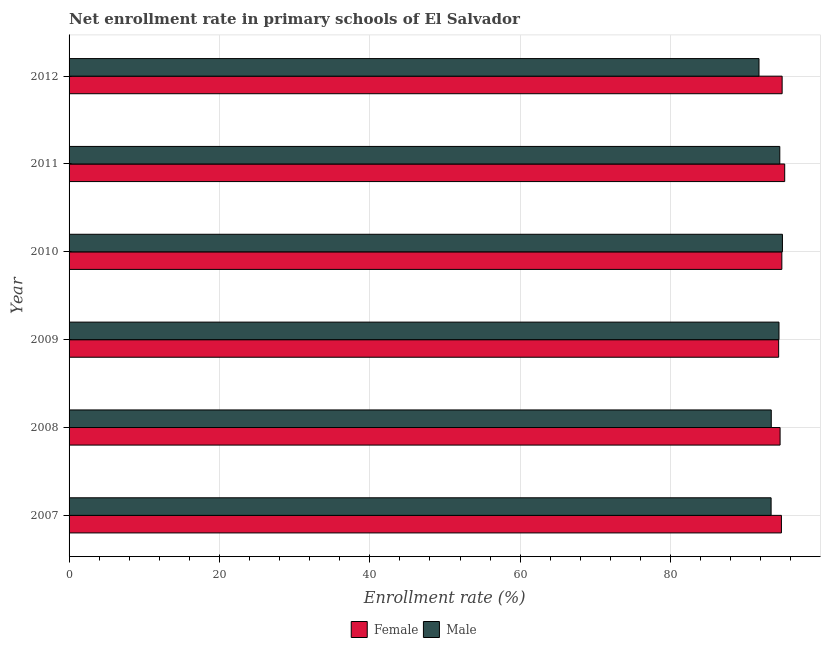How many different coloured bars are there?
Offer a very short reply. 2. How many groups of bars are there?
Provide a short and direct response. 6. Are the number of bars on each tick of the Y-axis equal?
Your answer should be very brief. Yes. In how many cases, is the number of bars for a given year not equal to the number of legend labels?
Your response must be concise. 0. What is the enrollment rate of female students in 2011?
Your answer should be very brief. 95.19. Across all years, what is the maximum enrollment rate of male students?
Make the answer very short. 94.89. Across all years, what is the minimum enrollment rate of male students?
Provide a short and direct response. 91.77. In which year was the enrollment rate of male students maximum?
Offer a very short reply. 2010. What is the total enrollment rate of female students in the graph?
Your response must be concise. 568.55. What is the difference between the enrollment rate of female students in 2007 and that in 2008?
Your answer should be compact. 0.18. What is the difference between the enrollment rate of female students in 2010 and the enrollment rate of male students in 2012?
Give a very brief answer. 3.04. What is the average enrollment rate of male students per year?
Provide a succinct answer. 93.73. In the year 2007, what is the difference between the enrollment rate of female students and enrollment rate of male students?
Keep it short and to the point. 1.37. What is the difference between the highest and the second highest enrollment rate of female students?
Your answer should be very brief. 0.34. What is the difference between the highest and the lowest enrollment rate of male students?
Your answer should be very brief. 3.12. In how many years, is the enrollment rate of male students greater than the average enrollment rate of male students taken over all years?
Your answer should be compact. 3. What does the 2nd bar from the top in 2011 represents?
Provide a succinct answer. Female. What does the 1st bar from the bottom in 2008 represents?
Ensure brevity in your answer.  Female. How many bars are there?
Offer a very short reply. 12. How many years are there in the graph?
Ensure brevity in your answer.  6. What is the difference between two consecutive major ticks on the X-axis?
Offer a very short reply. 20. Does the graph contain any zero values?
Offer a terse response. No. Does the graph contain grids?
Your answer should be compact. Yes. Where does the legend appear in the graph?
Keep it short and to the point. Bottom center. How many legend labels are there?
Make the answer very short. 2. How are the legend labels stacked?
Offer a terse response. Horizontal. What is the title of the graph?
Provide a short and direct response. Net enrollment rate in primary schools of El Salvador. What is the label or title of the X-axis?
Provide a succinct answer. Enrollment rate (%). What is the label or title of the Y-axis?
Keep it short and to the point. Year. What is the Enrollment rate (%) of Female in 2007?
Ensure brevity in your answer.  94.75. What is the Enrollment rate (%) in Male in 2007?
Offer a very short reply. 93.38. What is the Enrollment rate (%) in Female in 2008?
Your answer should be compact. 94.57. What is the Enrollment rate (%) in Male in 2008?
Keep it short and to the point. 93.4. What is the Enrollment rate (%) of Female in 2009?
Provide a succinct answer. 94.38. What is the Enrollment rate (%) of Male in 2009?
Give a very brief answer. 94.43. What is the Enrollment rate (%) of Female in 2010?
Ensure brevity in your answer.  94.81. What is the Enrollment rate (%) in Male in 2010?
Your answer should be very brief. 94.89. What is the Enrollment rate (%) in Female in 2011?
Your response must be concise. 95.19. What is the Enrollment rate (%) of Male in 2011?
Keep it short and to the point. 94.53. What is the Enrollment rate (%) of Female in 2012?
Provide a succinct answer. 94.85. What is the Enrollment rate (%) of Male in 2012?
Your response must be concise. 91.77. Across all years, what is the maximum Enrollment rate (%) in Female?
Offer a very short reply. 95.19. Across all years, what is the maximum Enrollment rate (%) of Male?
Keep it short and to the point. 94.89. Across all years, what is the minimum Enrollment rate (%) of Female?
Make the answer very short. 94.38. Across all years, what is the minimum Enrollment rate (%) in Male?
Provide a short and direct response. 91.77. What is the total Enrollment rate (%) in Female in the graph?
Ensure brevity in your answer.  568.55. What is the total Enrollment rate (%) of Male in the graph?
Your answer should be compact. 562.39. What is the difference between the Enrollment rate (%) in Female in 2007 and that in 2008?
Give a very brief answer. 0.18. What is the difference between the Enrollment rate (%) of Male in 2007 and that in 2008?
Provide a short and direct response. -0.02. What is the difference between the Enrollment rate (%) of Female in 2007 and that in 2009?
Make the answer very short. 0.37. What is the difference between the Enrollment rate (%) of Male in 2007 and that in 2009?
Give a very brief answer. -1.05. What is the difference between the Enrollment rate (%) in Female in 2007 and that in 2010?
Your answer should be very brief. -0.06. What is the difference between the Enrollment rate (%) in Male in 2007 and that in 2010?
Your response must be concise. -1.51. What is the difference between the Enrollment rate (%) of Female in 2007 and that in 2011?
Give a very brief answer. -0.44. What is the difference between the Enrollment rate (%) in Male in 2007 and that in 2011?
Offer a terse response. -1.16. What is the difference between the Enrollment rate (%) in Female in 2007 and that in 2012?
Your answer should be very brief. -0.09. What is the difference between the Enrollment rate (%) in Male in 2007 and that in 2012?
Offer a terse response. 1.61. What is the difference between the Enrollment rate (%) of Female in 2008 and that in 2009?
Keep it short and to the point. 0.19. What is the difference between the Enrollment rate (%) in Male in 2008 and that in 2009?
Your answer should be compact. -1.03. What is the difference between the Enrollment rate (%) of Female in 2008 and that in 2010?
Provide a succinct answer. -0.23. What is the difference between the Enrollment rate (%) of Male in 2008 and that in 2010?
Offer a terse response. -1.49. What is the difference between the Enrollment rate (%) of Female in 2008 and that in 2011?
Your response must be concise. -0.61. What is the difference between the Enrollment rate (%) of Male in 2008 and that in 2011?
Offer a terse response. -1.13. What is the difference between the Enrollment rate (%) of Female in 2008 and that in 2012?
Keep it short and to the point. -0.27. What is the difference between the Enrollment rate (%) in Male in 2008 and that in 2012?
Offer a very short reply. 1.63. What is the difference between the Enrollment rate (%) in Female in 2009 and that in 2010?
Your response must be concise. -0.42. What is the difference between the Enrollment rate (%) of Male in 2009 and that in 2010?
Your answer should be compact. -0.46. What is the difference between the Enrollment rate (%) in Female in 2009 and that in 2011?
Make the answer very short. -0.8. What is the difference between the Enrollment rate (%) in Male in 2009 and that in 2011?
Provide a succinct answer. -0.11. What is the difference between the Enrollment rate (%) in Female in 2009 and that in 2012?
Ensure brevity in your answer.  -0.46. What is the difference between the Enrollment rate (%) of Male in 2009 and that in 2012?
Offer a very short reply. 2.66. What is the difference between the Enrollment rate (%) in Female in 2010 and that in 2011?
Make the answer very short. -0.38. What is the difference between the Enrollment rate (%) in Male in 2010 and that in 2011?
Ensure brevity in your answer.  0.35. What is the difference between the Enrollment rate (%) in Female in 2010 and that in 2012?
Provide a succinct answer. -0.04. What is the difference between the Enrollment rate (%) in Male in 2010 and that in 2012?
Keep it short and to the point. 3.12. What is the difference between the Enrollment rate (%) in Female in 2011 and that in 2012?
Give a very brief answer. 0.34. What is the difference between the Enrollment rate (%) in Male in 2011 and that in 2012?
Your response must be concise. 2.77. What is the difference between the Enrollment rate (%) in Female in 2007 and the Enrollment rate (%) in Male in 2008?
Offer a very short reply. 1.35. What is the difference between the Enrollment rate (%) in Female in 2007 and the Enrollment rate (%) in Male in 2009?
Offer a very short reply. 0.32. What is the difference between the Enrollment rate (%) in Female in 2007 and the Enrollment rate (%) in Male in 2010?
Offer a very short reply. -0.13. What is the difference between the Enrollment rate (%) of Female in 2007 and the Enrollment rate (%) of Male in 2011?
Your answer should be compact. 0.22. What is the difference between the Enrollment rate (%) of Female in 2007 and the Enrollment rate (%) of Male in 2012?
Your response must be concise. 2.98. What is the difference between the Enrollment rate (%) in Female in 2008 and the Enrollment rate (%) in Male in 2009?
Your response must be concise. 0.15. What is the difference between the Enrollment rate (%) in Female in 2008 and the Enrollment rate (%) in Male in 2010?
Make the answer very short. -0.31. What is the difference between the Enrollment rate (%) in Female in 2008 and the Enrollment rate (%) in Male in 2011?
Give a very brief answer. 0.04. What is the difference between the Enrollment rate (%) of Female in 2008 and the Enrollment rate (%) of Male in 2012?
Provide a succinct answer. 2.8. What is the difference between the Enrollment rate (%) of Female in 2009 and the Enrollment rate (%) of Male in 2010?
Your answer should be compact. -0.5. What is the difference between the Enrollment rate (%) in Female in 2009 and the Enrollment rate (%) in Male in 2011?
Give a very brief answer. -0.15. What is the difference between the Enrollment rate (%) of Female in 2009 and the Enrollment rate (%) of Male in 2012?
Make the answer very short. 2.61. What is the difference between the Enrollment rate (%) of Female in 2010 and the Enrollment rate (%) of Male in 2011?
Your response must be concise. 0.27. What is the difference between the Enrollment rate (%) of Female in 2010 and the Enrollment rate (%) of Male in 2012?
Keep it short and to the point. 3.04. What is the difference between the Enrollment rate (%) in Female in 2011 and the Enrollment rate (%) in Male in 2012?
Your answer should be compact. 3.42. What is the average Enrollment rate (%) in Female per year?
Offer a terse response. 94.76. What is the average Enrollment rate (%) of Male per year?
Keep it short and to the point. 93.73. In the year 2007, what is the difference between the Enrollment rate (%) in Female and Enrollment rate (%) in Male?
Provide a short and direct response. 1.37. In the year 2008, what is the difference between the Enrollment rate (%) in Female and Enrollment rate (%) in Male?
Provide a succinct answer. 1.17. In the year 2009, what is the difference between the Enrollment rate (%) of Female and Enrollment rate (%) of Male?
Your answer should be compact. -0.04. In the year 2010, what is the difference between the Enrollment rate (%) in Female and Enrollment rate (%) in Male?
Your answer should be very brief. -0.08. In the year 2011, what is the difference between the Enrollment rate (%) in Female and Enrollment rate (%) in Male?
Keep it short and to the point. 0.65. In the year 2012, what is the difference between the Enrollment rate (%) in Female and Enrollment rate (%) in Male?
Give a very brief answer. 3.08. What is the ratio of the Enrollment rate (%) of Male in 2007 to that in 2008?
Keep it short and to the point. 1. What is the ratio of the Enrollment rate (%) of Female in 2007 to that in 2009?
Your answer should be very brief. 1. What is the ratio of the Enrollment rate (%) in Male in 2007 to that in 2009?
Offer a very short reply. 0.99. What is the ratio of the Enrollment rate (%) of Male in 2007 to that in 2010?
Offer a very short reply. 0.98. What is the ratio of the Enrollment rate (%) of Female in 2007 to that in 2011?
Offer a terse response. 1. What is the ratio of the Enrollment rate (%) of Female in 2007 to that in 2012?
Provide a short and direct response. 1. What is the ratio of the Enrollment rate (%) of Male in 2007 to that in 2012?
Offer a terse response. 1.02. What is the ratio of the Enrollment rate (%) of Male in 2008 to that in 2009?
Keep it short and to the point. 0.99. What is the ratio of the Enrollment rate (%) of Male in 2008 to that in 2010?
Offer a terse response. 0.98. What is the ratio of the Enrollment rate (%) of Female in 2008 to that in 2011?
Your answer should be very brief. 0.99. What is the ratio of the Enrollment rate (%) in Male in 2008 to that in 2011?
Your answer should be compact. 0.99. What is the ratio of the Enrollment rate (%) of Female in 2008 to that in 2012?
Provide a short and direct response. 1. What is the ratio of the Enrollment rate (%) in Male in 2008 to that in 2012?
Give a very brief answer. 1.02. What is the ratio of the Enrollment rate (%) in Female in 2009 to that in 2010?
Provide a succinct answer. 1. What is the ratio of the Enrollment rate (%) of Male in 2009 to that in 2010?
Offer a very short reply. 1. What is the ratio of the Enrollment rate (%) in Female in 2009 to that in 2011?
Provide a short and direct response. 0.99. What is the ratio of the Enrollment rate (%) in Female in 2009 to that in 2012?
Your answer should be compact. 1. What is the ratio of the Enrollment rate (%) in Male in 2010 to that in 2012?
Your answer should be very brief. 1.03. What is the ratio of the Enrollment rate (%) of Male in 2011 to that in 2012?
Provide a short and direct response. 1.03. What is the difference between the highest and the second highest Enrollment rate (%) in Female?
Give a very brief answer. 0.34. What is the difference between the highest and the second highest Enrollment rate (%) in Male?
Ensure brevity in your answer.  0.35. What is the difference between the highest and the lowest Enrollment rate (%) of Female?
Provide a short and direct response. 0.8. What is the difference between the highest and the lowest Enrollment rate (%) in Male?
Your answer should be compact. 3.12. 